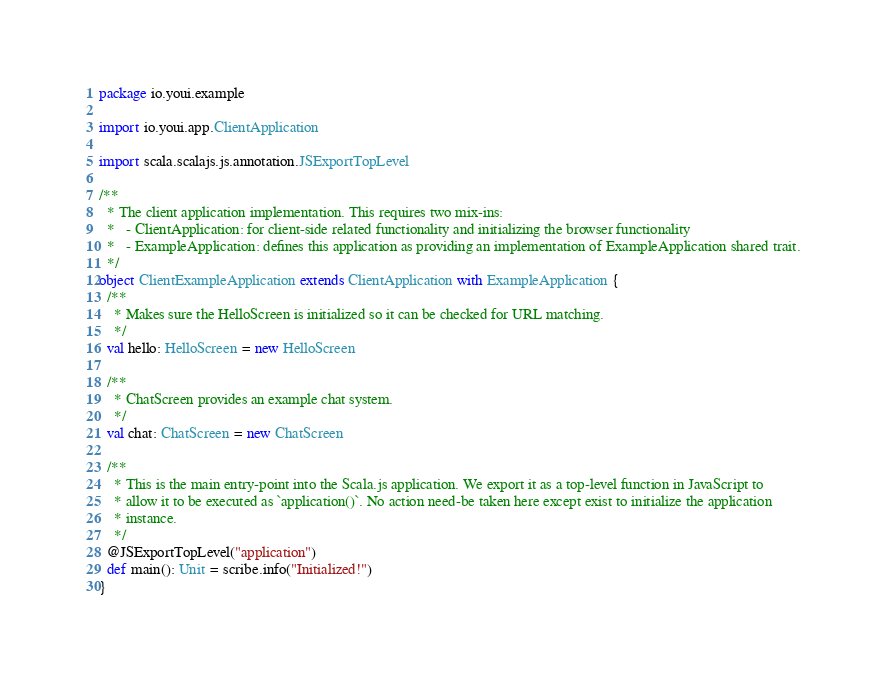<code> <loc_0><loc_0><loc_500><loc_500><_Scala_>package io.youi.example

import io.youi.app.ClientApplication

import scala.scalajs.js.annotation.JSExportTopLevel

/**
  * The client application implementation. This requires two mix-ins:
  *   - ClientApplication: for client-side related functionality and initializing the browser functionality
  *   - ExampleApplication: defines this application as providing an implementation of ExampleApplication shared trait.
  */
object ClientExampleApplication extends ClientApplication with ExampleApplication {
  /**
    * Makes sure the HelloScreen is initialized so it can be checked for URL matching.
    */
  val hello: HelloScreen = new HelloScreen

  /**
    * ChatScreen provides an example chat system.
    */
  val chat: ChatScreen = new ChatScreen

  /**
    * This is the main entry-point into the Scala.js application. We export it as a top-level function in JavaScript to
    * allow it to be executed as `application()`. No action need-be taken here except exist to initialize the application
    * instance.
    */
  @JSExportTopLevel("application")
  def main(): Unit = scribe.info("Initialized!")
}
</code> 